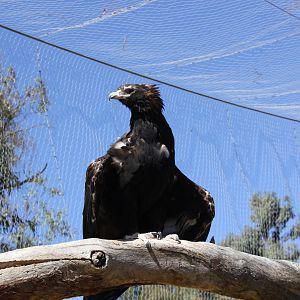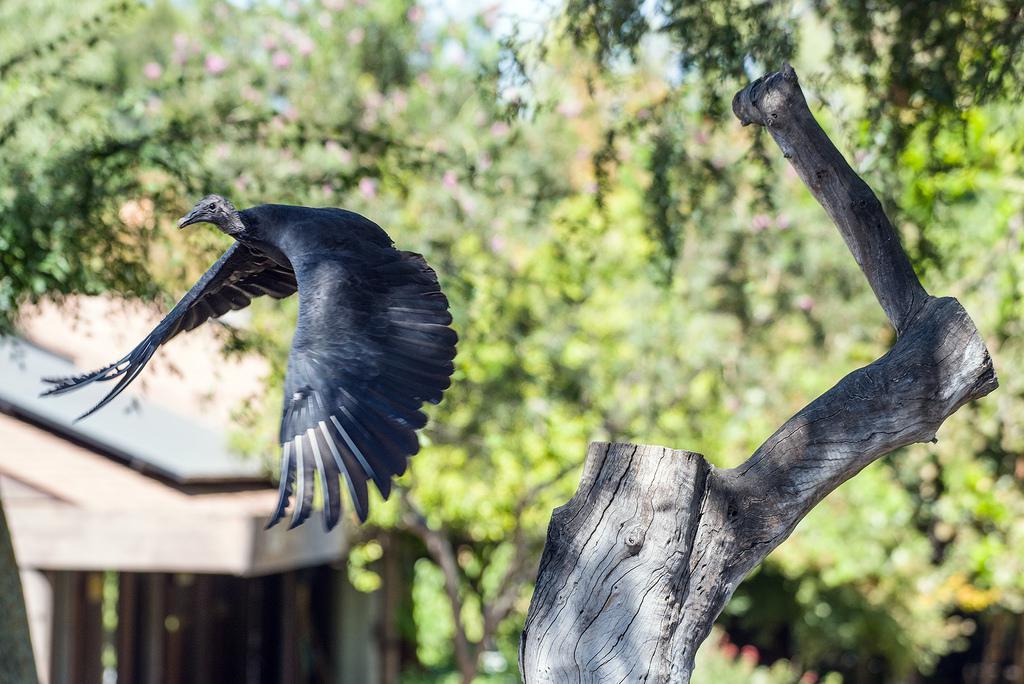The first image is the image on the left, the second image is the image on the right. For the images shown, is this caption "The left and right image contains a total of two vultures facing different directions." true? Answer yes or no. No. The first image is the image on the left, the second image is the image on the right. Considering the images on both sides, is "The left image contains one vulture perched on a leafless branch, with its wings tucked." valid? Answer yes or no. Yes. 